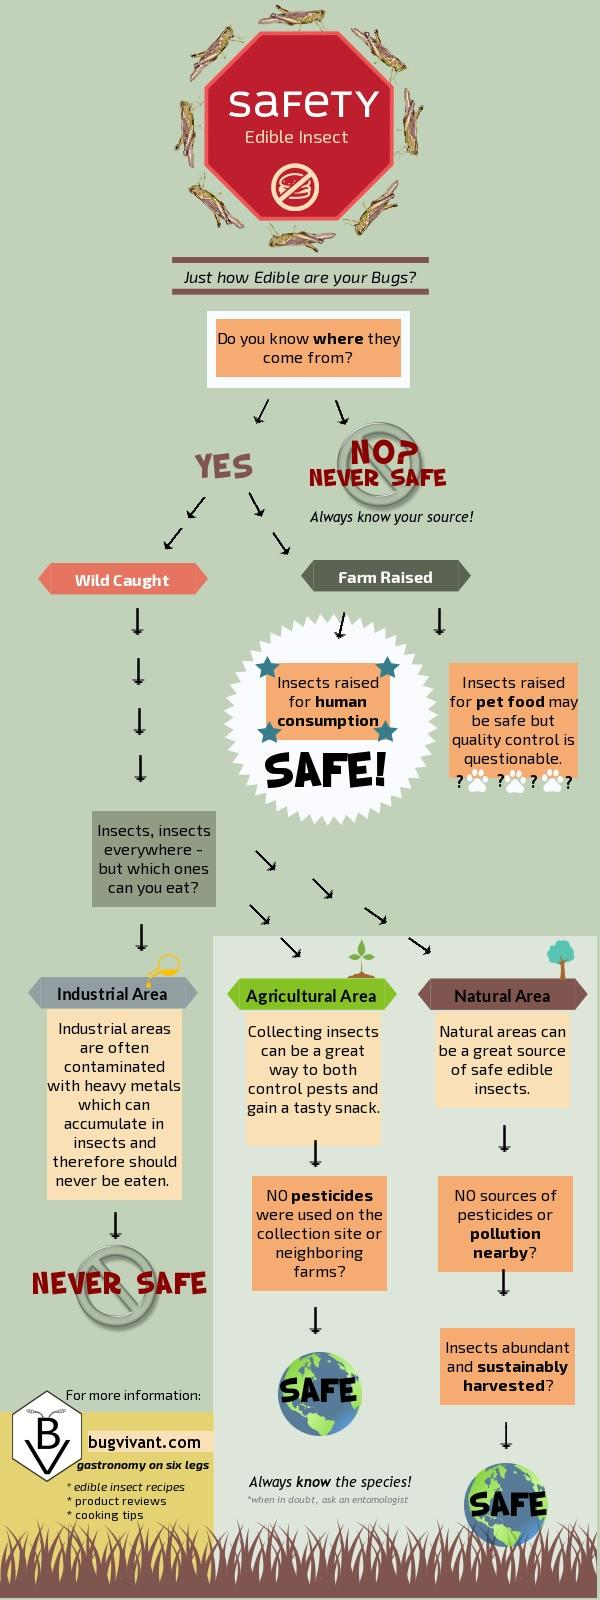Highlight a few significant elements in this photo. There are 3 areas mentioned in this infographic. It is unsafe for human consumption to consume edible insects from the industrial area. There are two ways to obtain insects: wild caught or farm raised. The infographic covers areas such as industrial, agricultural, and natural areas. There are eight insect icons present in this infographic. 